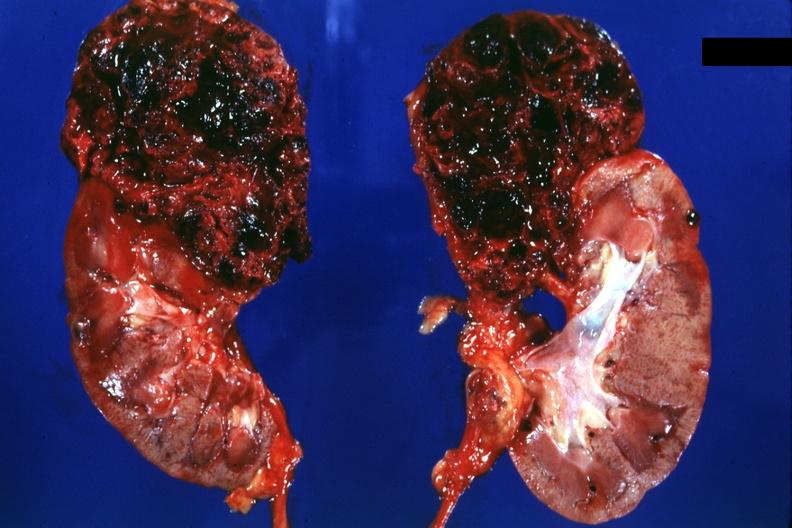what does this image show?
Answer the question using a single word or phrase. Two halves of kidney with superior pole very hemorrhagic tumor 